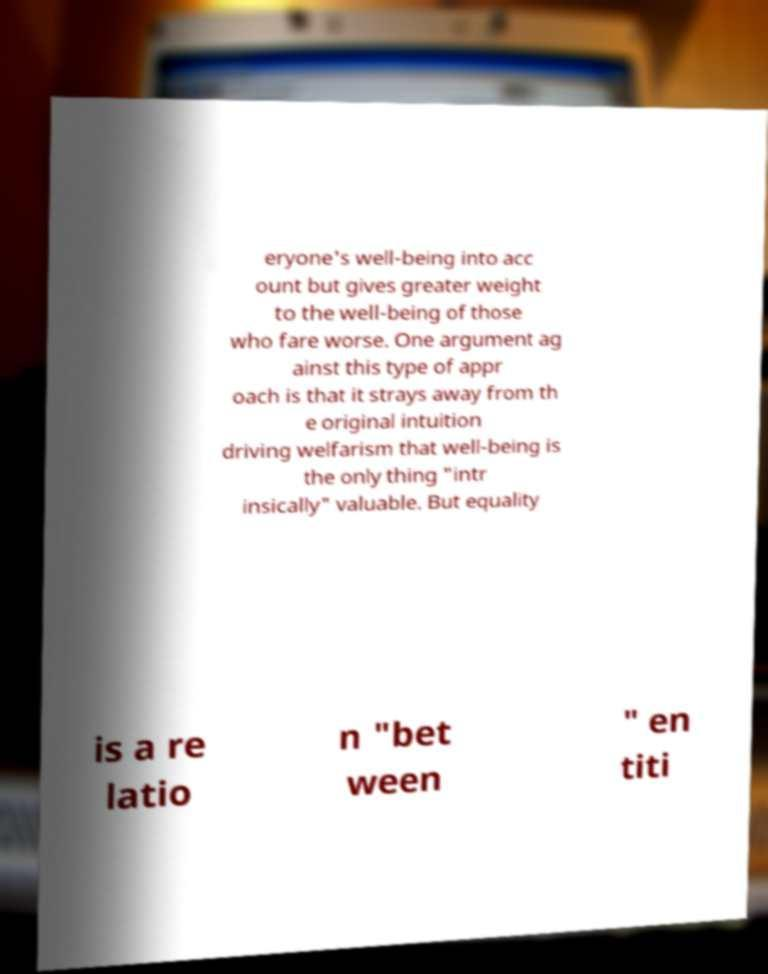I need the written content from this picture converted into text. Can you do that? eryone's well-being into acc ount but gives greater weight to the well-being of those who fare worse. One argument ag ainst this type of appr oach is that it strays away from th e original intuition driving welfarism that well-being is the only thing "intr insically" valuable. But equality is a re latio n "bet ween " en titi 